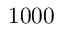<formula> <loc_0><loc_0><loc_500><loc_500>1 0 0 0</formula> 